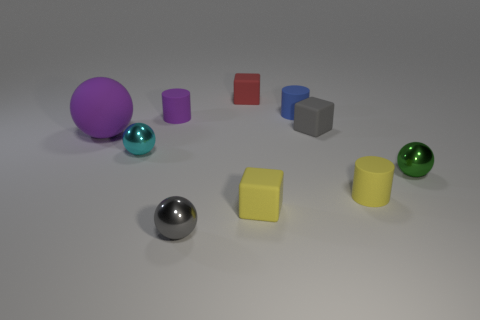There is a large rubber ball; is its color the same as the small shiny ball that is behind the green sphere?
Provide a succinct answer. No. There is a tiny shiny object that is behind the green ball; what is its shape?
Offer a very short reply. Sphere. What number of other things are the same material as the small green ball?
Your answer should be compact. 2. What material is the tiny cyan thing?
Provide a short and direct response. Metal. What number of large things are red things or blue shiny cubes?
Your response must be concise. 0. How many small green shiny spheres are behind the gray matte block?
Ensure brevity in your answer.  0. Are there any metal spheres that have the same color as the matte sphere?
Ensure brevity in your answer.  No. There is a green metal object that is the same size as the cyan ball; what shape is it?
Your answer should be compact. Sphere. How many purple things are either big rubber balls or tiny shiny things?
Offer a very short reply. 1. How many red rubber objects are the same size as the cyan metal thing?
Make the answer very short. 1. 